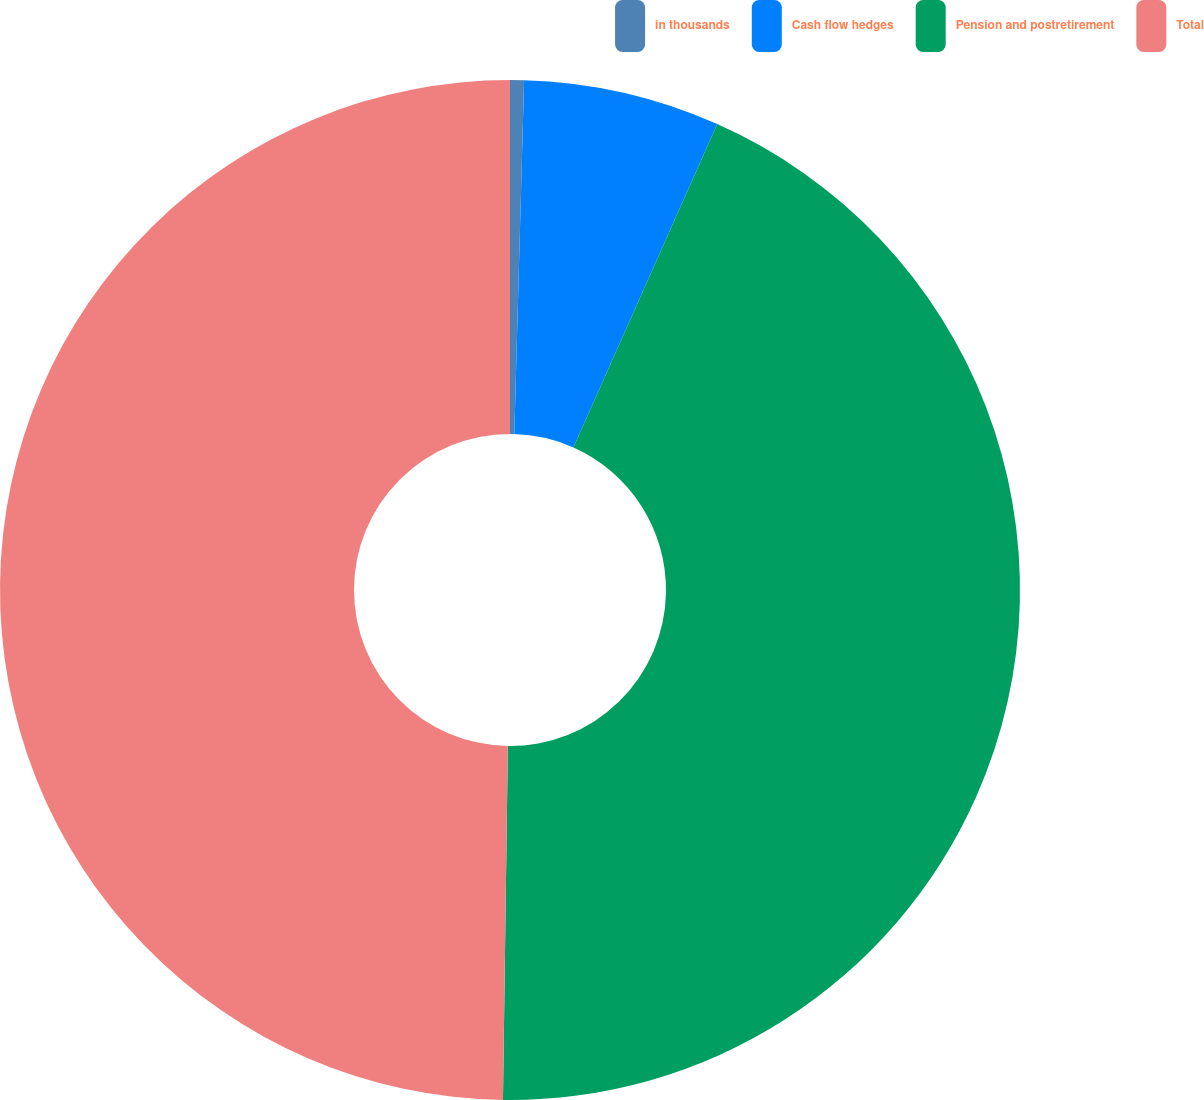Convert chart to OTSL. <chart><loc_0><loc_0><loc_500><loc_500><pie_chart><fcel>in thousands<fcel>Cash flow hedges<fcel>Pension and postretirement<fcel>Total<nl><fcel>0.44%<fcel>6.22%<fcel>43.56%<fcel>49.78%<nl></chart> 